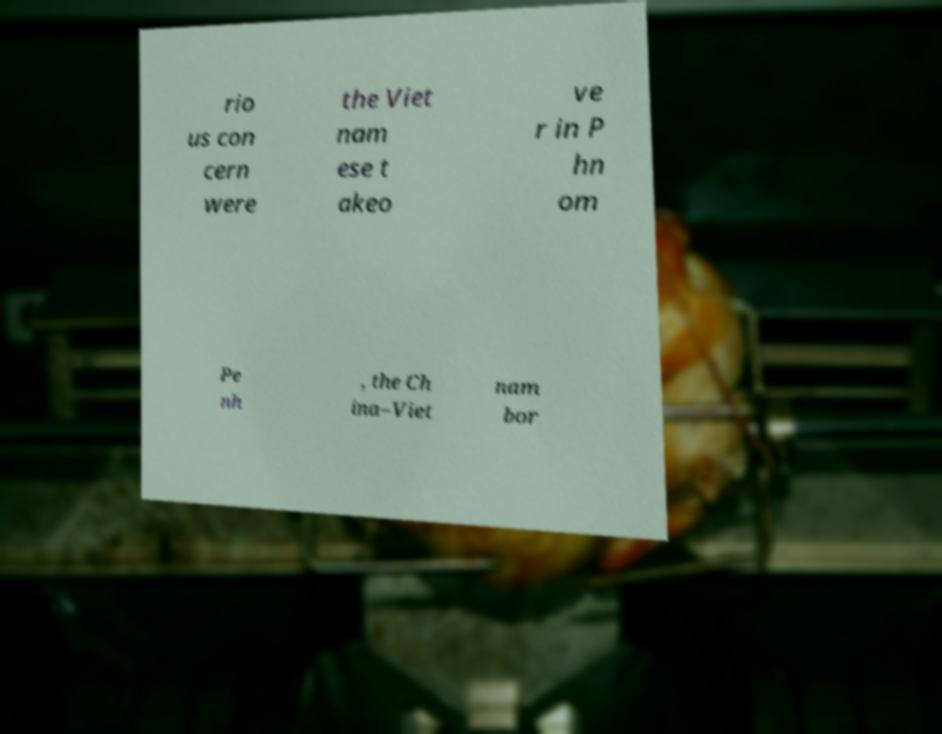There's text embedded in this image that I need extracted. Can you transcribe it verbatim? rio us con cern were the Viet nam ese t akeo ve r in P hn om Pe nh , the Ch ina–Viet nam bor 